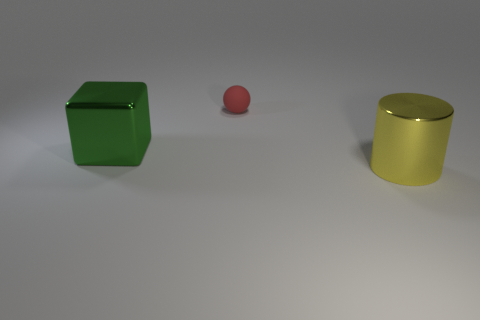Is there any other thing that is the same material as the red sphere?
Make the answer very short. No. What shape is the object that is behind the big yellow metallic cylinder and in front of the small sphere?
Provide a succinct answer. Cube. What number of large cyan cylinders are there?
Ensure brevity in your answer.  0. There is a shiny object that is on the right side of the green shiny object; what color is it?
Your answer should be very brief. Yellow. How many other things are the same size as the matte sphere?
Keep it short and to the point. 0. Is there any other thing that is the same shape as the large yellow shiny thing?
Provide a succinct answer. No. Are there an equal number of green shiny cubes that are on the right side of the big cube and yellow cylinders?
Make the answer very short. No. How many yellow cylinders are made of the same material as the big green cube?
Provide a short and direct response. 1. The other large object that is the same material as the green thing is what color?
Offer a terse response. Yellow. Does the red rubber thing have the same shape as the yellow object?
Provide a succinct answer. No. 